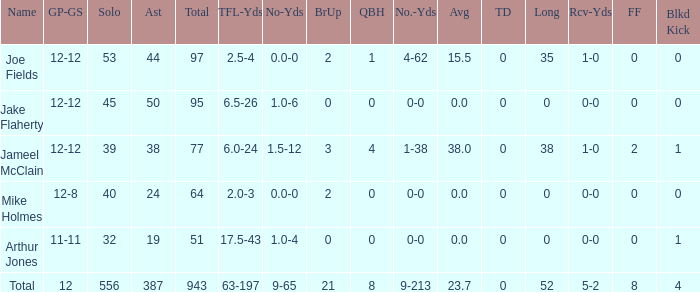How many players named jake flaherty? 1.0. 